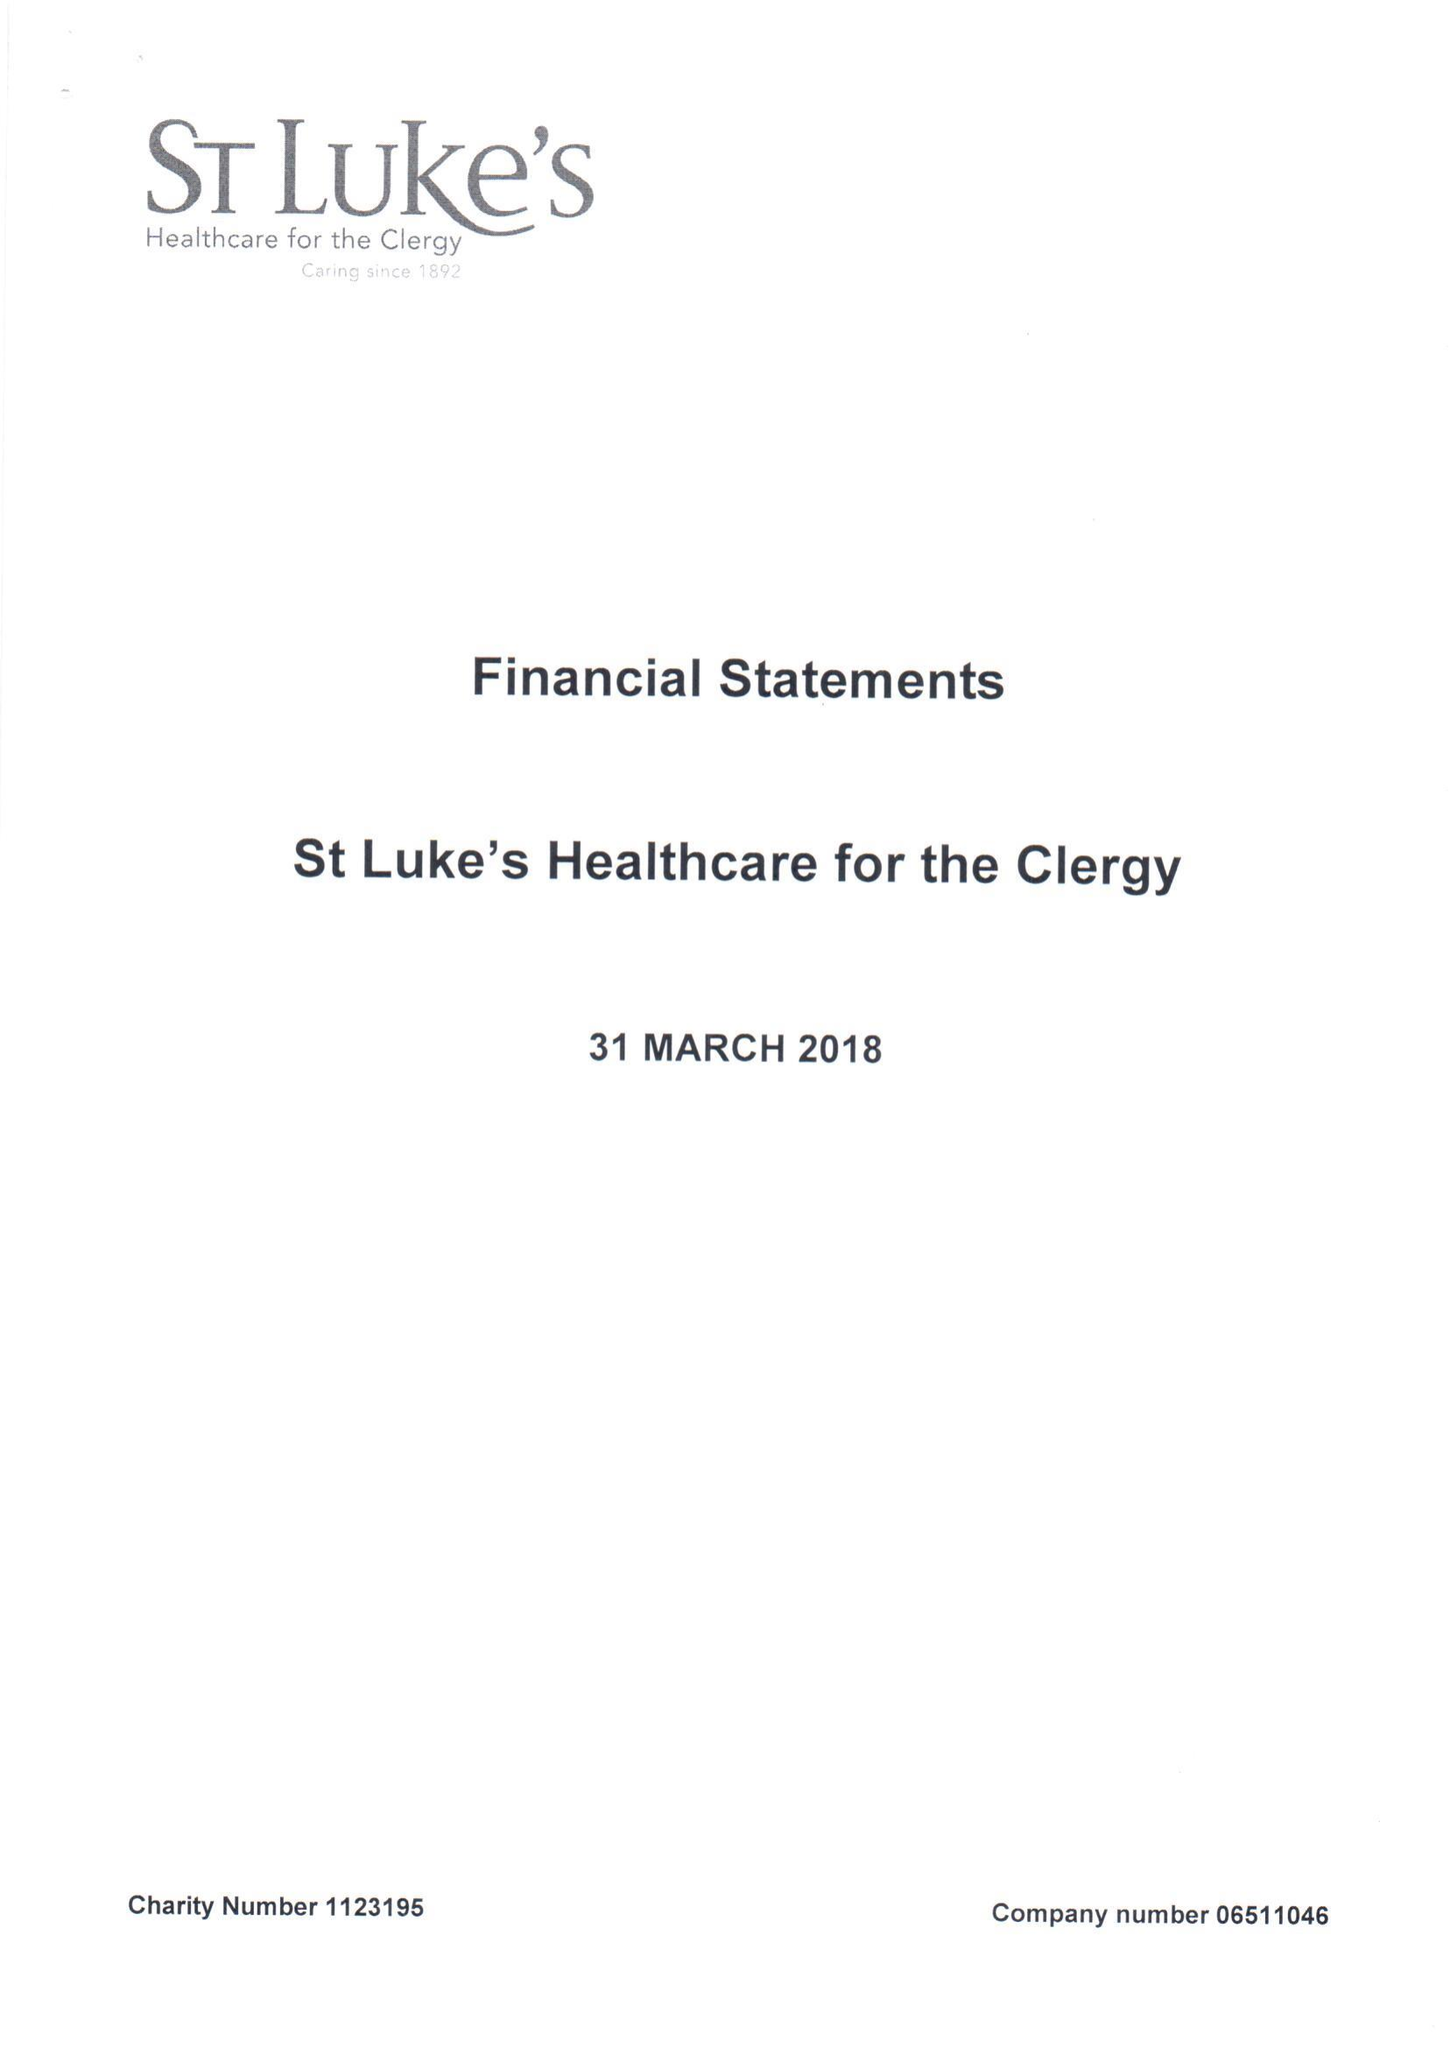What is the value for the income_annually_in_british_pounds?
Answer the question using a single word or phrase. 203415.00 